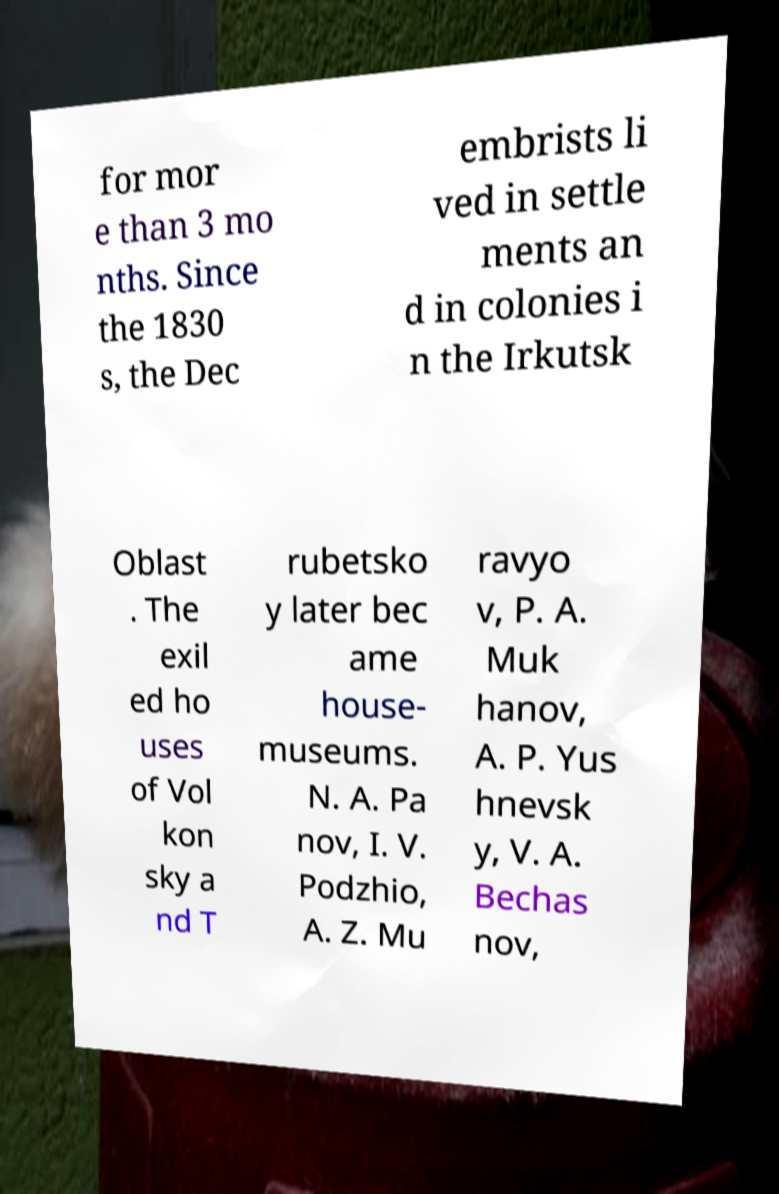Could you extract and type out the text from this image? for mor e than 3 mo nths. Since the 1830 s, the Dec embrists li ved in settle ments an d in colonies i n the Irkutsk Oblast . The exil ed ho uses of Vol kon sky a nd T rubetsko y later bec ame house- museums. N. A. Pa nov, I. V. Podzhio, A. Z. Mu ravyo v, P. A. Muk hanov, A. P. Yus hnevsk y, V. A. Bechas nov, 